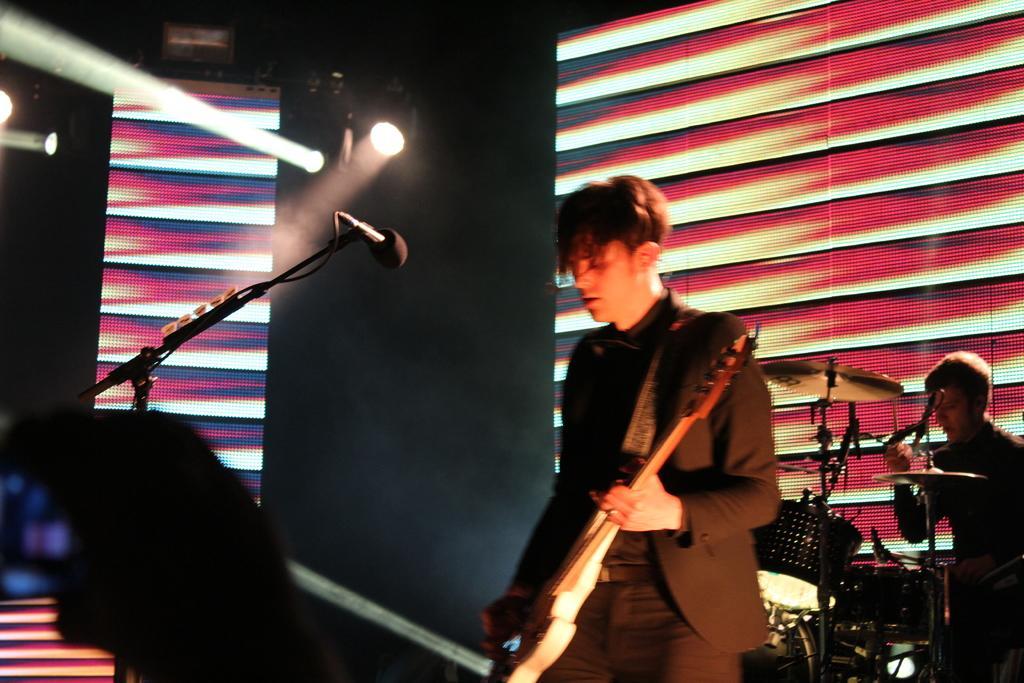Can you describe this image briefly? This image is taken inside a room. There are three people in the room. The man in the center wore a black suit and playing a guitar. The man at the right corner is sitting and playing drums. At the left corner of the image there is a hand of a person holding mobile phone. There is a microphone and microphone stand in the image. In the background there is a screen, wall and lights 